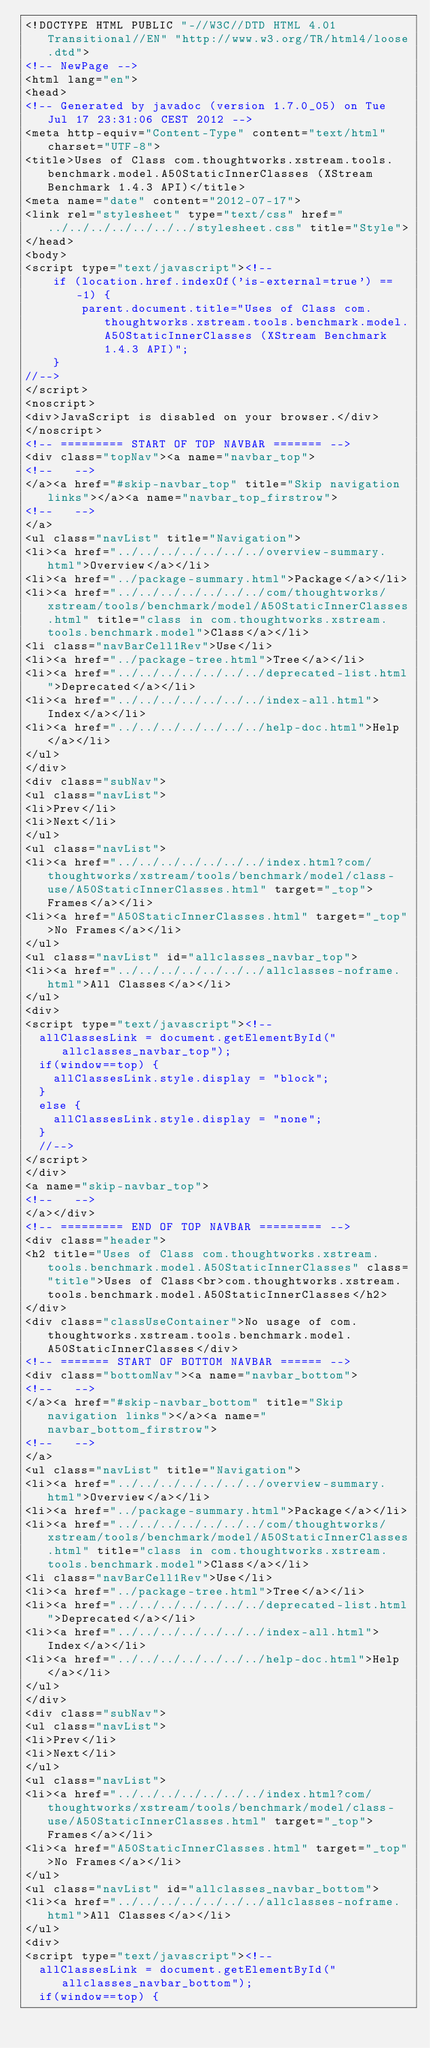<code> <loc_0><loc_0><loc_500><loc_500><_HTML_><!DOCTYPE HTML PUBLIC "-//W3C//DTD HTML 4.01 Transitional//EN" "http://www.w3.org/TR/html4/loose.dtd">
<!-- NewPage -->
<html lang="en">
<head>
<!-- Generated by javadoc (version 1.7.0_05) on Tue Jul 17 23:31:06 CEST 2012 -->
<meta http-equiv="Content-Type" content="text/html" charset="UTF-8">
<title>Uses of Class com.thoughtworks.xstream.tools.benchmark.model.A50StaticInnerClasses (XStream Benchmark 1.4.3 API)</title>
<meta name="date" content="2012-07-17">
<link rel="stylesheet" type="text/css" href="../../../../../../../stylesheet.css" title="Style">
</head>
<body>
<script type="text/javascript"><!--
    if (location.href.indexOf('is-external=true') == -1) {
        parent.document.title="Uses of Class com.thoughtworks.xstream.tools.benchmark.model.A50StaticInnerClasses (XStream Benchmark 1.4.3 API)";
    }
//-->
</script>
<noscript>
<div>JavaScript is disabled on your browser.</div>
</noscript>
<!-- ========= START OF TOP NAVBAR ======= -->
<div class="topNav"><a name="navbar_top">
<!--   -->
</a><a href="#skip-navbar_top" title="Skip navigation links"></a><a name="navbar_top_firstrow">
<!--   -->
</a>
<ul class="navList" title="Navigation">
<li><a href="../../../../../../../overview-summary.html">Overview</a></li>
<li><a href="../package-summary.html">Package</a></li>
<li><a href="../../../../../../../com/thoughtworks/xstream/tools/benchmark/model/A50StaticInnerClasses.html" title="class in com.thoughtworks.xstream.tools.benchmark.model">Class</a></li>
<li class="navBarCell1Rev">Use</li>
<li><a href="../package-tree.html">Tree</a></li>
<li><a href="../../../../../../../deprecated-list.html">Deprecated</a></li>
<li><a href="../../../../../../../index-all.html">Index</a></li>
<li><a href="../../../../../../../help-doc.html">Help</a></li>
</ul>
</div>
<div class="subNav">
<ul class="navList">
<li>Prev</li>
<li>Next</li>
</ul>
<ul class="navList">
<li><a href="../../../../../../../index.html?com/thoughtworks/xstream/tools/benchmark/model/class-use/A50StaticInnerClasses.html" target="_top">Frames</a></li>
<li><a href="A50StaticInnerClasses.html" target="_top">No Frames</a></li>
</ul>
<ul class="navList" id="allclasses_navbar_top">
<li><a href="../../../../../../../allclasses-noframe.html">All Classes</a></li>
</ul>
<div>
<script type="text/javascript"><!--
  allClassesLink = document.getElementById("allclasses_navbar_top");
  if(window==top) {
    allClassesLink.style.display = "block";
  }
  else {
    allClassesLink.style.display = "none";
  }
  //-->
</script>
</div>
<a name="skip-navbar_top">
<!--   -->
</a></div>
<!-- ========= END OF TOP NAVBAR ========= -->
<div class="header">
<h2 title="Uses of Class com.thoughtworks.xstream.tools.benchmark.model.A50StaticInnerClasses" class="title">Uses of Class<br>com.thoughtworks.xstream.tools.benchmark.model.A50StaticInnerClasses</h2>
</div>
<div class="classUseContainer">No usage of com.thoughtworks.xstream.tools.benchmark.model.A50StaticInnerClasses</div>
<!-- ======= START OF BOTTOM NAVBAR ====== -->
<div class="bottomNav"><a name="navbar_bottom">
<!--   -->
</a><a href="#skip-navbar_bottom" title="Skip navigation links"></a><a name="navbar_bottom_firstrow">
<!--   -->
</a>
<ul class="navList" title="Navigation">
<li><a href="../../../../../../../overview-summary.html">Overview</a></li>
<li><a href="../package-summary.html">Package</a></li>
<li><a href="../../../../../../../com/thoughtworks/xstream/tools/benchmark/model/A50StaticInnerClasses.html" title="class in com.thoughtworks.xstream.tools.benchmark.model">Class</a></li>
<li class="navBarCell1Rev">Use</li>
<li><a href="../package-tree.html">Tree</a></li>
<li><a href="../../../../../../../deprecated-list.html">Deprecated</a></li>
<li><a href="../../../../../../../index-all.html">Index</a></li>
<li><a href="../../../../../../../help-doc.html">Help</a></li>
</ul>
</div>
<div class="subNav">
<ul class="navList">
<li>Prev</li>
<li>Next</li>
</ul>
<ul class="navList">
<li><a href="../../../../../../../index.html?com/thoughtworks/xstream/tools/benchmark/model/class-use/A50StaticInnerClasses.html" target="_top">Frames</a></li>
<li><a href="A50StaticInnerClasses.html" target="_top">No Frames</a></li>
</ul>
<ul class="navList" id="allclasses_navbar_bottom">
<li><a href="../../../../../../../allclasses-noframe.html">All Classes</a></li>
</ul>
<div>
<script type="text/javascript"><!--
  allClassesLink = document.getElementById("allclasses_navbar_bottom");
  if(window==top) {</code> 